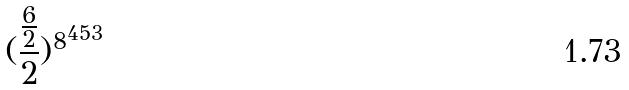<formula> <loc_0><loc_0><loc_500><loc_500>( \frac { \frac { 6 } { 2 } } { 2 } ) ^ { 8 ^ { 4 5 3 } }</formula> 